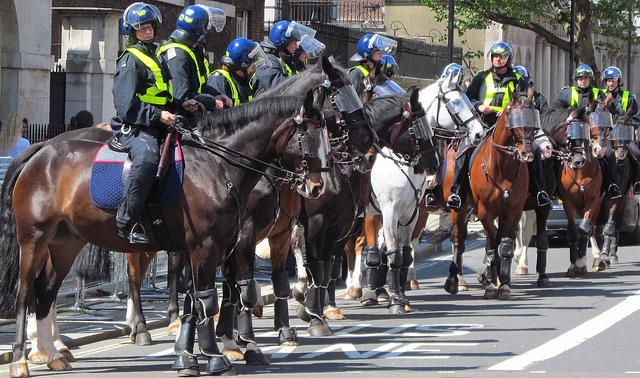Why do the horses wear leg coverings? protection 